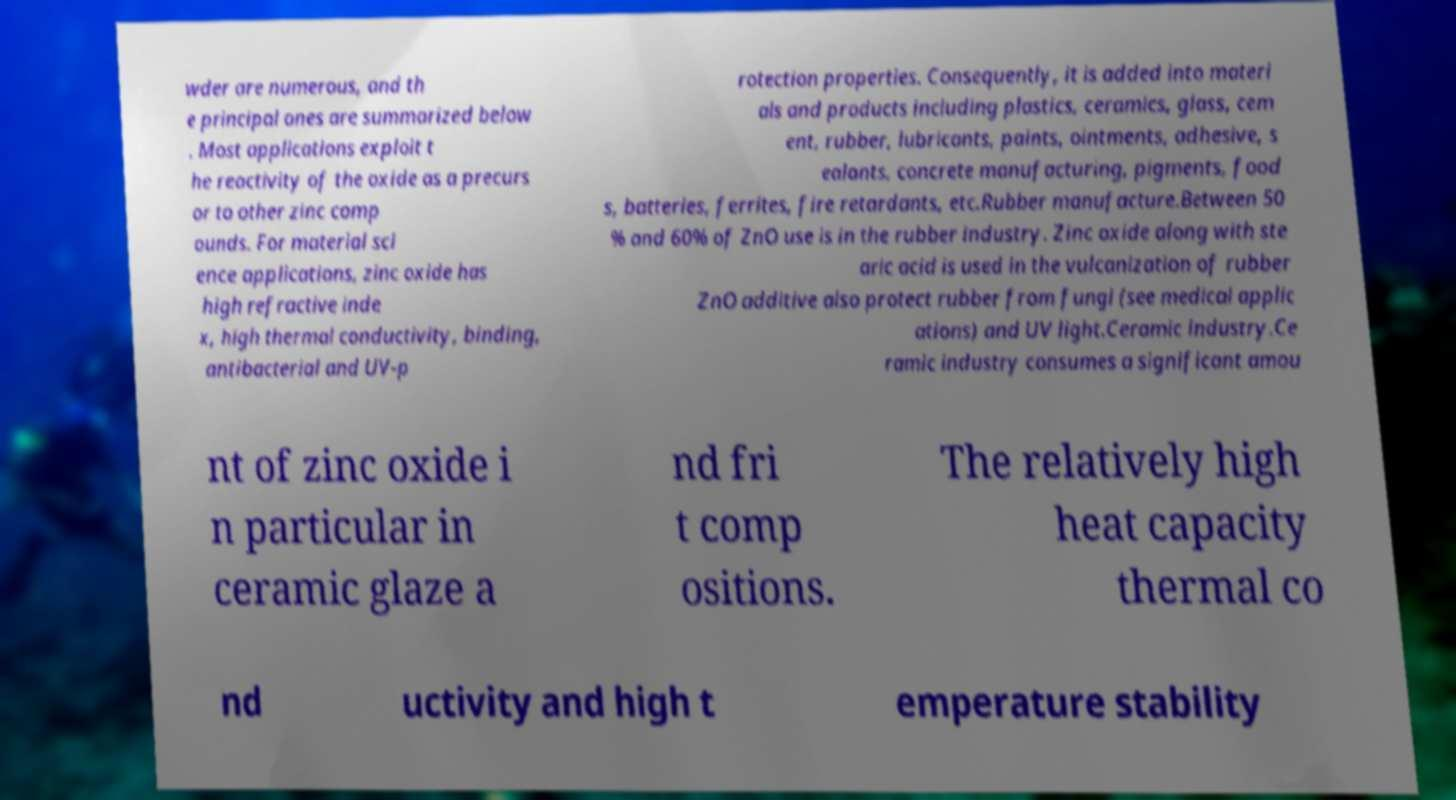Could you extract and type out the text from this image? wder are numerous, and th e principal ones are summarized below . Most applications exploit t he reactivity of the oxide as a precurs or to other zinc comp ounds. For material sci ence applications, zinc oxide has high refractive inde x, high thermal conductivity, binding, antibacterial and UV-p rotection properties. Consequently, it is added into materi als and products including plastics, ceramics, glass, cem ent, rubber, lubricants, paints, ointments, adhesive, s ealants, concrete manufacturing, pigments, food s, batteries, ferrites, fire retardants, etc.Rubber manufacture.Between 50 % and 60% of ZnO use is in the rubber industry. Zinc oxide along with ste aric acid is used in the vulcanization of rubber ZnO additive also protect rubber from fungi (see medical applic ations) and UV light.Ceramic industry.Ce ramic industry consumes a significant amou nt of zinc oxide i n particular in ceramic glaze a nd fri t comp ositions. The relatively high heat capacity thermal co nd uctivity and high t emperature stability 